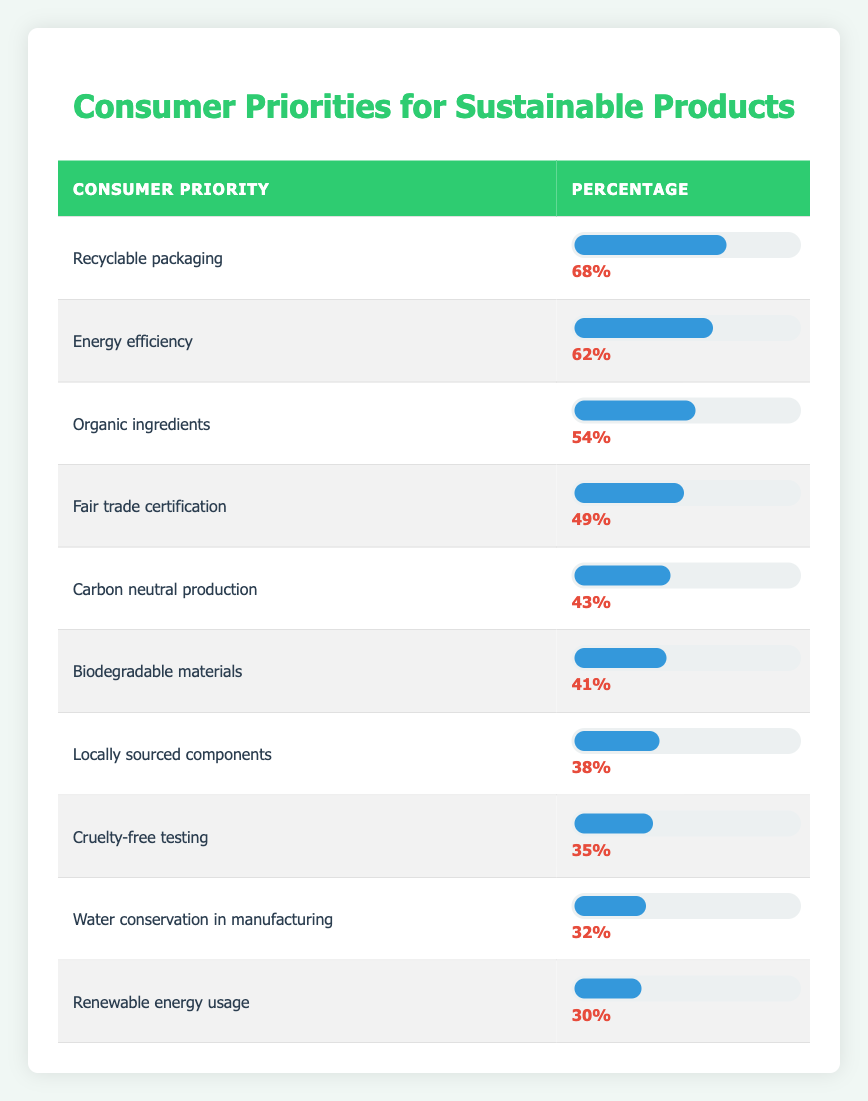What is the highest consumer priority for sustainable products? The table lists multiple consumer priorities with their corresponding percentages. By examining the percentages, "Recyclable packaging" has the highest percentage at 68%.
Answer: Recyclable packaging What percentage of consumers prioritize energy efficiency? The table displays the percentage for "Energy efficiency," which is listed as 62%.
Answer: 62% Is "Cruelty-free testing" a higher priority than "Water conservation in manufacturing"? By comparing the percentages in the table, "Cruelty-free testing" has a percentage of 35%, while "Water conservation in manufacturing" has 32%. Since 35% is greater than 32%, the answer is yes.
Answer: Yes What are the top three consumer priorities for sustainable products? The top three priorities, based on the highest percentages in the table, are "Recyclable packaging" (68%), "Energy efficiency" (62%), and "Organic ingredients" (54%).
Answer: Recyclable packaging, Energy efficiency, Organic ingredients What is the difference in percentage between "Biodegradable materials" and "Locally sourced components"? "Biodegradable materials" has a percentage of 41%, and "Locally sourced components" has 38%. The difference is calculated as 41% - 38% = 3%.
Answer: 3% What percentage of consumers prioritize both "Fair trade certification" and "Carbon neutral production"? "Fair trade certification" has 49%, and "Carbon neutral production" has 43%. To find the combined total, we add both percentages: 49% + 43% = 92%.
Answer: 92% Is "Renewable energy usage" prioritized by less than a third of consumers? In the table, "Renewable energy usage" is at 30%. Since 30% is indeed less than one third (33.33%), the answer is yes.
Answer: Yes What is the median consumer priority percentage in the table? To find the median, we first need to list the percentages in order: 30%, 32%, 35%, 38%, 41%, 43%, 49%, 54%, 62%, 68%. With 10 data points, the median will be the average of the 5th and 6th values: (41% + 43%) / 2 = 42%.
Answer: 42% Which is more important to consumers: "Carbon neutral production" or "Fair trade certification"? "Carbon neutral production" is at 43%, while "Fair trade certification" is 49%. Since 49% is greater than 43%, "Fair trade certification" is more important to consumers.
Answer: Fair trade certification 